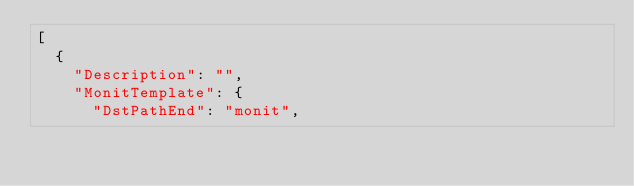<code> <loc_0><loc_0><loc_500><loc_500><_YAML_>[
  {
    "Description": "",
    "MonitTemplate": {
      "DstPathEnd": "monit",</code> 